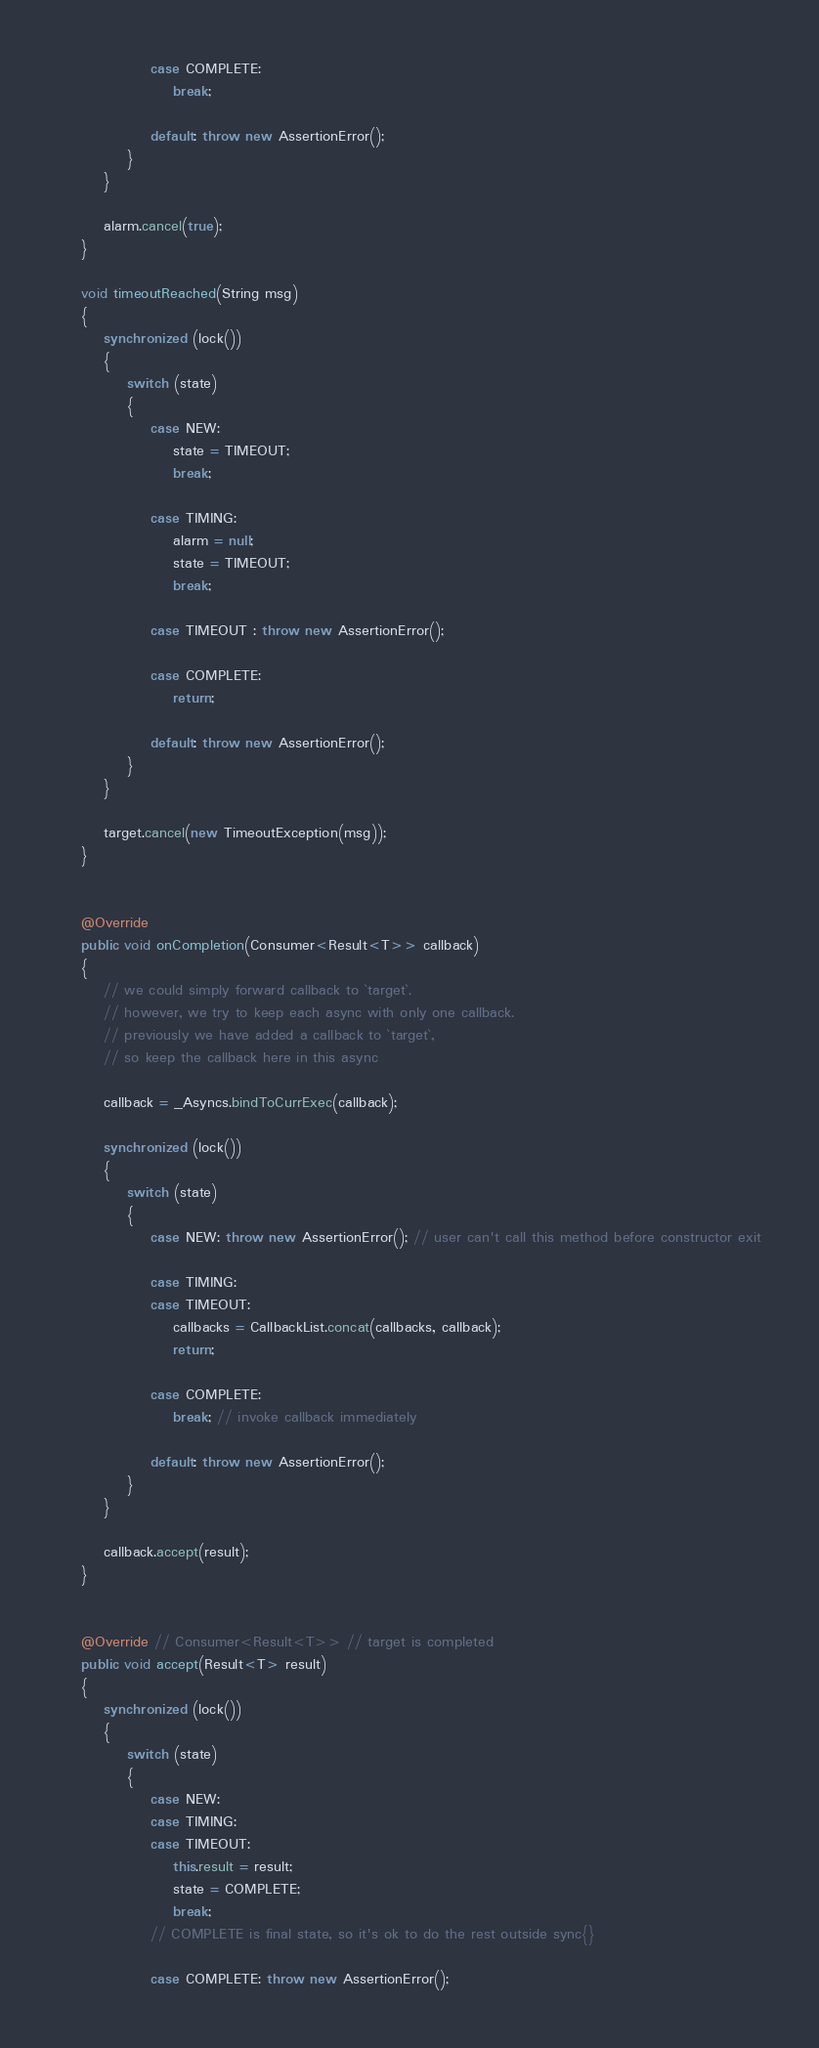<code> <loc_0><loc_0><loc_500><loc_500><_Java_>                case COMPLETE:
                    break;

                default: throw new AssertionError();
            }
        }

        alarm.cancel(true);
    }

    void timeoutReached(String msg)
    {
        synchronized (lock())
        {
            switch (state)
            {
                case NEW:
                    state = TIMEOUT;
                    break;

                case TIMING:
                    alarm = null;
                    state = TIMEOUT;
                    break;

                case TIMEOUT : throw new AssertionError();

                case COMPLETE:
                    return;

                default: throw new AssertionError();
            }
        }

        target.cancel(new TimeoutException(msg));
    }


    @Override
    public void onCompletion(Consumer<Result<T>> callback)
    {
        // we could simply forward callback to `target`.
        // however, we try to keep each async with only one callback.
        // previously we have added a callback to `target`,
        // so keep the callback here in this async

        callback = _Asyncs.bindToCurrExec(callback);

        synchronized (lock())
        {
            switch (state)
            {
                case NEW: throw new AssertionError(); // user can't call this method before constructor exit

                case TIMING:
                case TIMEOUT:
                    callbacks = CallbackList.concat(callbacks, callback);
                    return;

                case COMPLETE:
                    break; // invoke callback immediately

                default: throw new AssertionError();
            }
        }

        callback.accept(result);
    }


    @Override // Consumer<Result<T>> // target is completed
    public void accept(Result<T> result)
    {
        synchronized (lock())
        {
            switch (state)
            {
                case NEW:
                case TIMING:
                case TIMEOUT:
                    this.result = result;
                    state = COMPLETE;
                    break;
                // COMPLETE is final state, so it's ok to do the rest outside sync{}

                case COMPLETE: throw new AssertionError();
</code> 